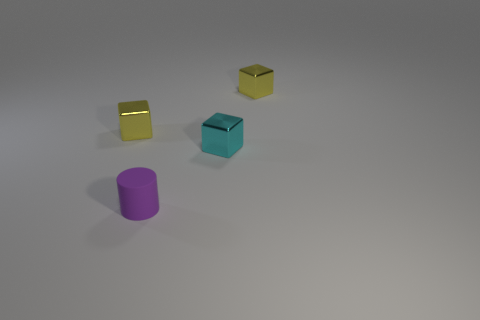What mood or atmosphere does this image convey? The image has a stark and serene ambiance, with sparsely positioned objects and a clean background. The cool color palette and soft lighting lend a tranquil and modern feel to the composition, which could be perceived as calming or contemplative. 